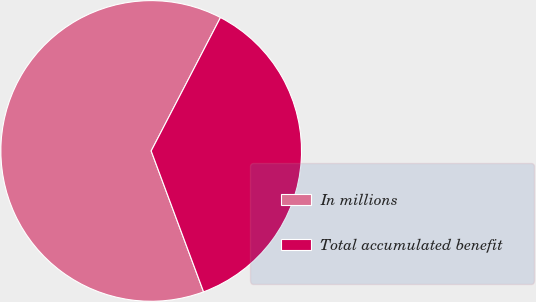<chart> <loc_0><loc_0><loc_500><loc_500><pie_chart><fcel>In millions<fcel>Total accumulated benefit<nl><fcel>63.29%<fcel>36.71%<nl></chart> 